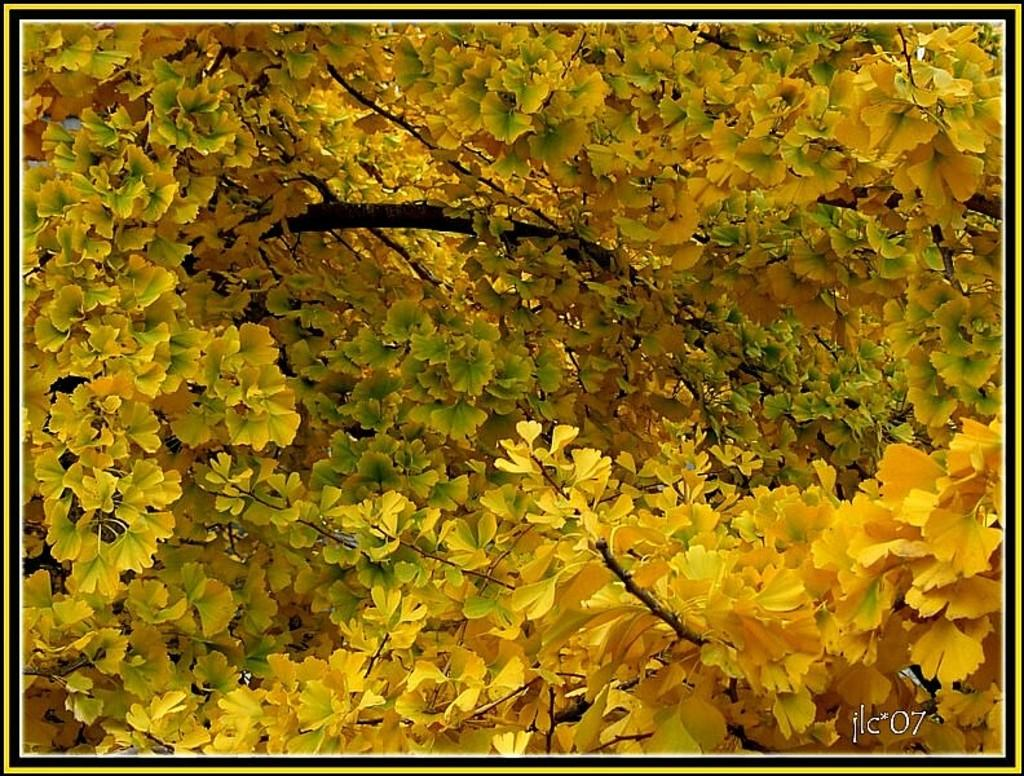What is the main subject of the image? The main subject of the image is a group of flowers. What can be said about the color of the flowers? The flowers are yellow in color. What type of plastic material can be seen in the image? There is no plastic material present in the image; it features a group of yellow flowers. Is there a hammer visible in the image? No, there is no hammer present in the image. 